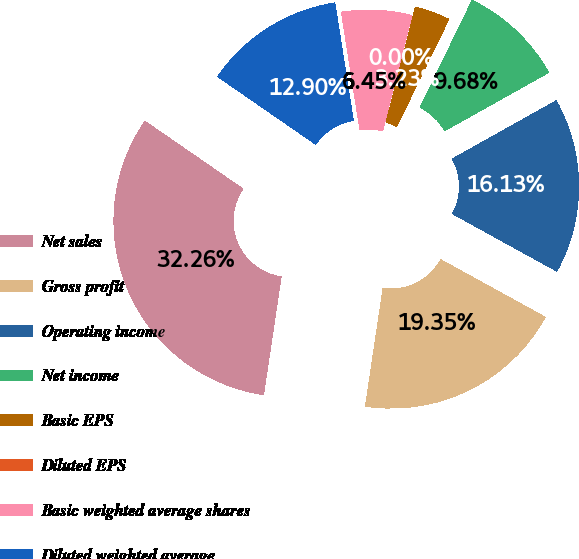Convert chart. <chart><loc_0><loc_0><loc_500><loc_500><pie_chart><fcel>Net sales<fcel>Gross profit<fcel>Operating income<fcel>Net income<fcel>Basic EPS<fcel>Diluted EPS<fcel>Basic weighted average shares<fcel>Diluted weighted average<nl><fcel>32.26%<fcel>19.35%<fcel>16.13%<fcel>9.68%<fcel>3.23%<fcel>0.0%<fcel>6.45%<fcel>12.9%<nl></chart> 